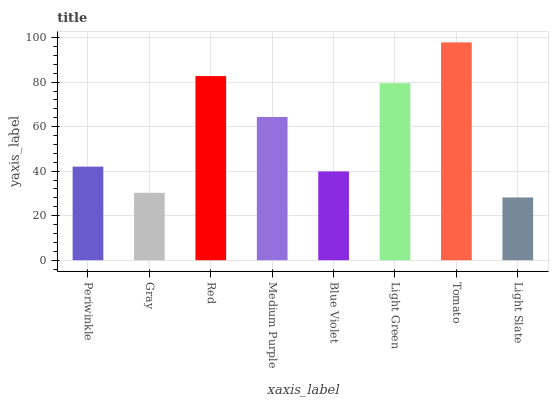Is Light Slate the minimum?
Answer yes or no. Yes. Is Tomato the maximum?
Answer yes or no. Yes. Is Gray the minimum?
Answer yes or no. No. Is Gray the maximum?
Answer yes or no. No. Is Periwinkle greater than Gray?
Answer yes or no. Yes. Is Gray less than Periwinkle?
Answer yes or no. Yes. Is Gray greater than Periwinkle?
Answer yes or no. No. Is Periwinkle less than Gray?
Answer yes or no. No. Is Medium Purple the high median?
Answer yes or no. Yes. Is Periwinkle the low median?
Answer yes or no. Yes. Is Periwinkle the high median?
Answer yes or no. No. Is Gray the low median?
Answer yes or no. No. 